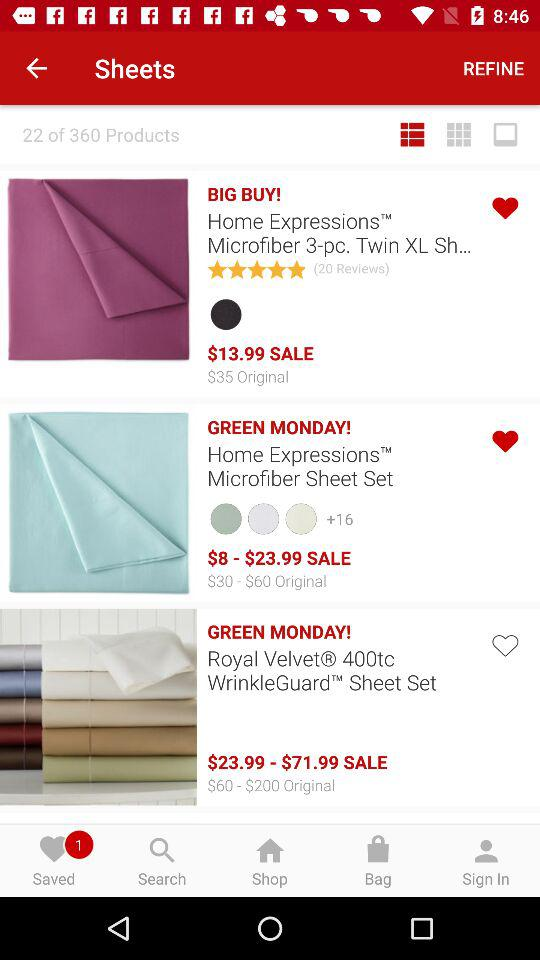Can you tell me more about the material and features of the Home Expressions Microfiber sheet set that is on sale? Certainly! The Home Expressions Microfiber Sheet Set boasts a soft and comfortable microfiber construction. Microfiber is known for its durability, as well as its ability to resist wrinkles and pilling. The set includes pieces such as a flat sheet, fitted sheet, and pillowcase(s), and it is available in a variety of colors, which are showcased by the color swatches on the product listing. 